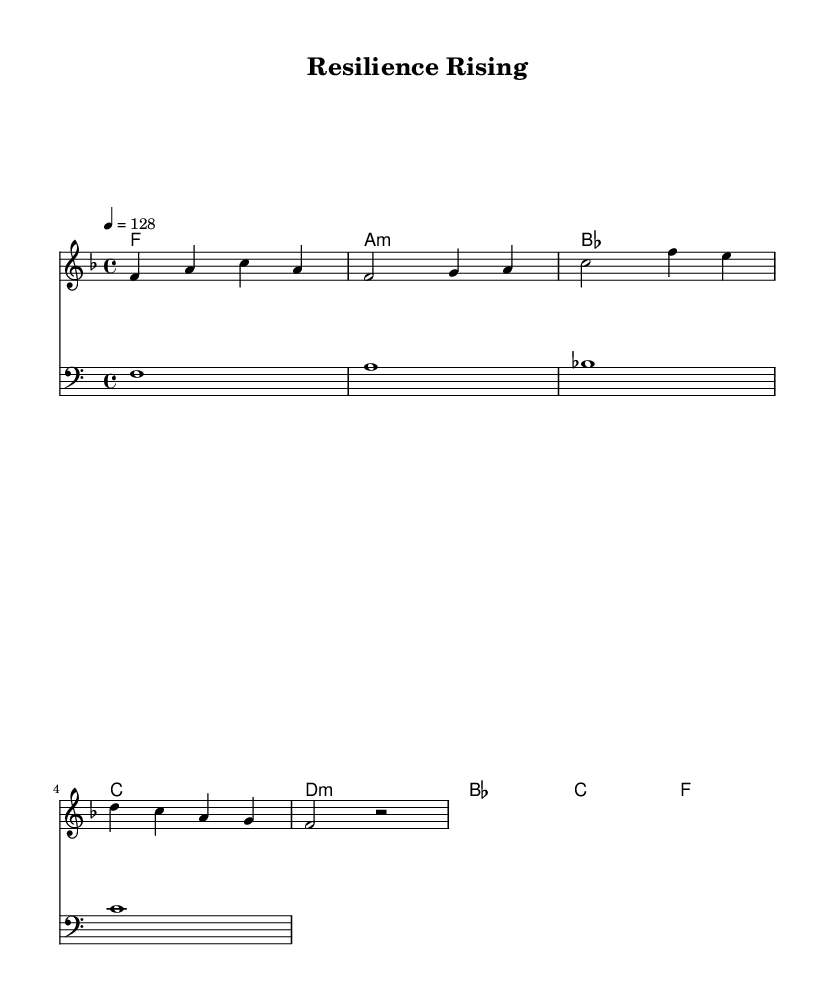What is the key signature of this music? The key signature is F major, which has one flat (B flat). This can be identified by looking at the key signature in the music sheet, which shows a single flat.
Answer: F major What is the time signature of this music? The time signature is 4/4, indicated at the beginning of the music sheet. It can be found in the measure shown after the key signature.
Answer: 4/4 What is the tempo marking indicated in the music? The tempo marking indicates a speed of 128 beats per minute, specified at the top of the sheet. This means the music should be played at this tempo.
Answer: 128 How many measures are in the melody? There are six measures in the melody section, which can be counted by looking at the divisions in the music. Each segment separated by vertical lines represents a measure.
Answer: 6 What is the root note of the first chord in the harmony? The root note of the first chord is F, which can be seen as the music starts with an F major chord. This corresponds to the first symbol in the harmony line.
Answer: F What type of chord follows the F major chord? The chord that follows is an A minor chord, identified by the chord symbol "a:m" in the harmony line. This chord is the second in the sequence after F.
Answer: A minor Which voice plays the bass line? The bass line is played by the bass staff, which is indicated by the clef used at the beginning of that staff. The clef specifies that this staff is for lower vocal ranges or instruments.
Answer: Bass 